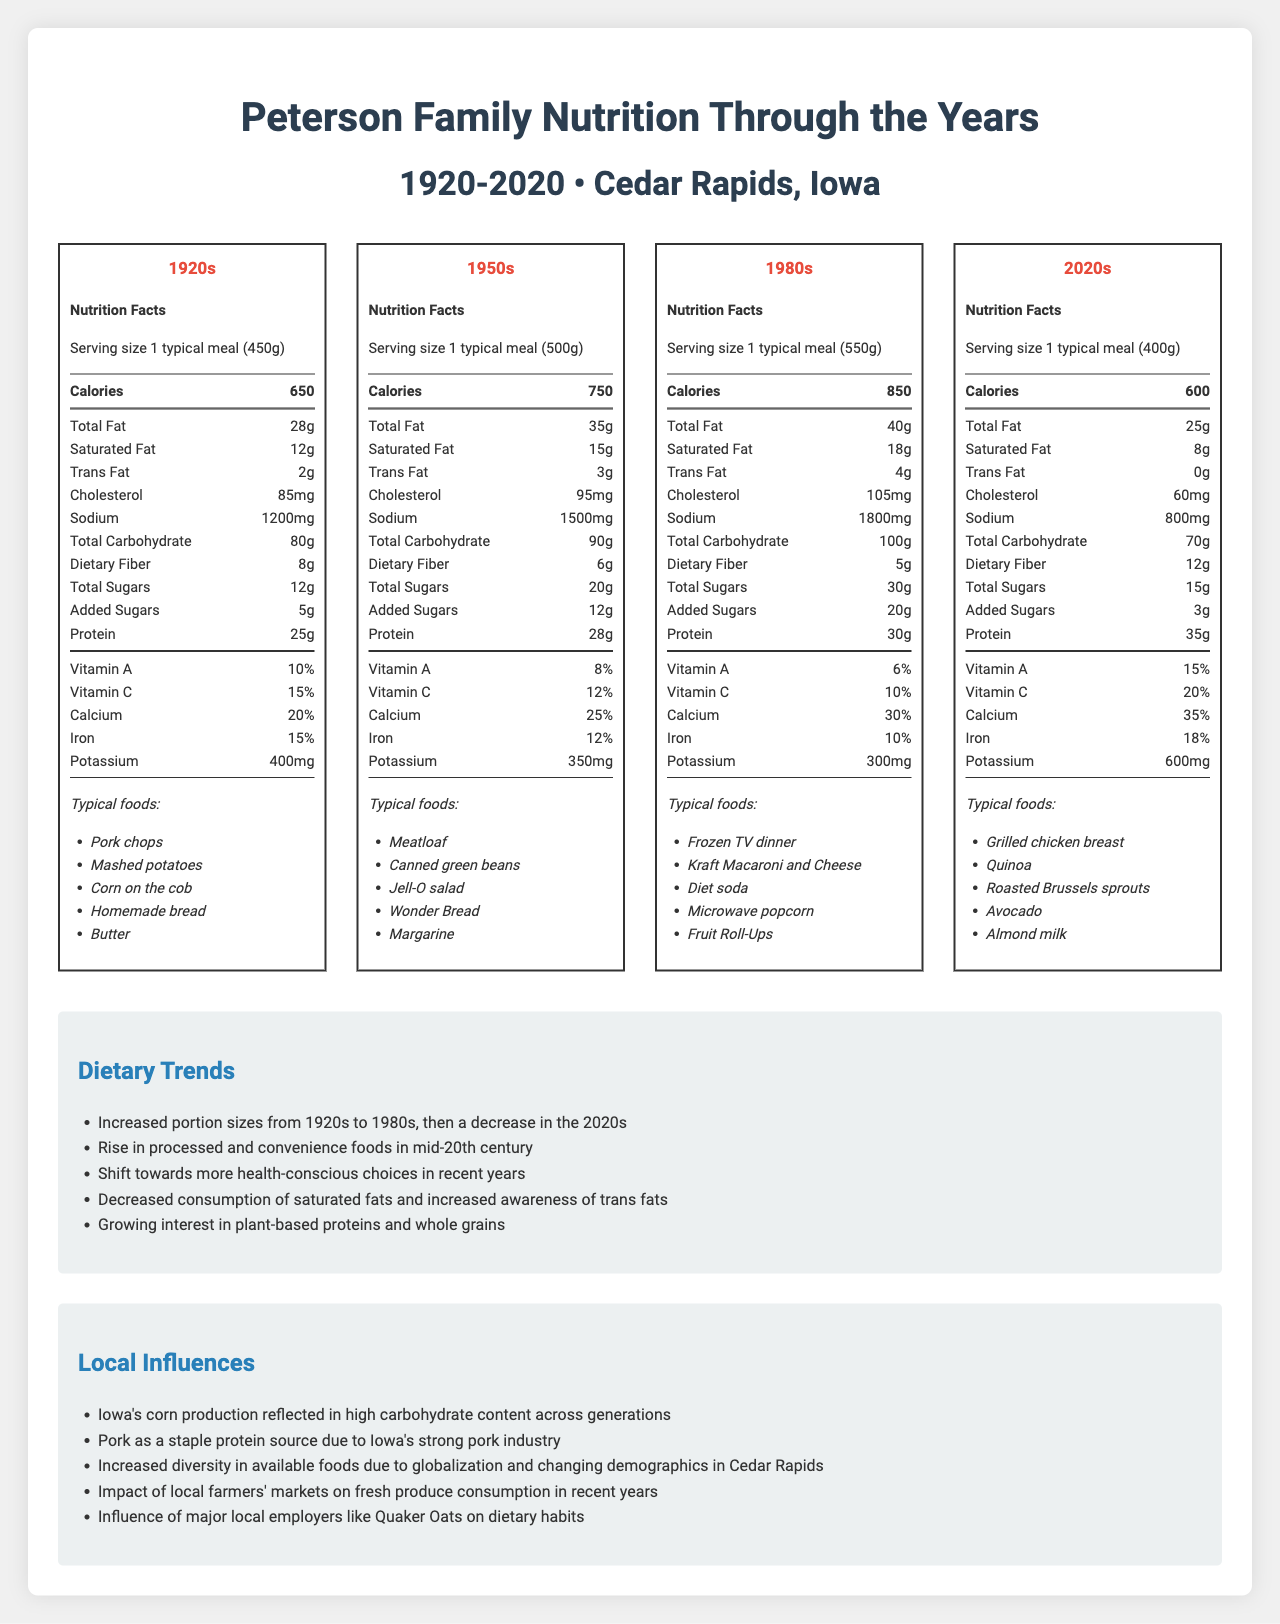how many calories are in a typical meal from the 1950s? According to the nutrition label from the 1950s era, a typical meal contains 750 calories.
Answer: 750 calories what is the serving size described for the 1980s? The nutrition label for the 1980s specifies that the serving size is "1 typical meal (550g)".
Answer: 1 typical meal (550g) how much protein is in a 2020s meal? The 2020s nutrition label lists 35 grams of protein per typical meal.
Answer: 35g what were the typical foods in the 1920s? The nutrition label for the 1920s lists these foods as typical for that era.
Answer: Pork chops, Mashed potatoes, Corn on the cob, Homemade bread, Butter which era had the highest sodium content in their meals? Meals from the 1980s had the highest sodium content at 1800mg.
Answer: 1980s which of the following foods is listed under the 1950s typical meal? A. Kraft Macaroni and Cheese B. Jell-O salad C. Avocado D. Quinoa The 1950s lists Jell-O salad as a typical food. The other options are from different eras.
Answer: B. Jell-O salad in which era did meals have the highest total carbohydrate content? A. 1920s B. 1950s C. 1980s D. 2020s Meals in the 1980s had the highest total carbohydrate content at 100g.
Answer: C. 1980s are there any trans fats listed in a 2020s meal? The nutrition label for the 2020s shows 0g of trans fats.
Answer: No summarize the main idea of the document. The document provides detailed nutrition facts per era, shows how dietary habits evolved, and identifies factors impacting those changes.
Answer: The document showcases the dietary changes in the Peterson family from Cedar Rapids, Iowa, over a timespan of 100 years (1920-2020). It highlights nutritional information, typical foods, dietary trends, and local influences across four different eras (1920s, 1950s, 1980s, and 2020s). The document observes increasing portion sizes from 1920s to 1980s, the rise of processed foods in the mid-20th century, and a shift towards health-conscious choices in recent years. It also notes the influences of local agriculture and global food diversification. what is the trend in added sugars content over the years? The 1920s had 5g of added sugars, the 1950s had 12g, the 1980s had 20g, and the 2020s had 3g.
Answer: The added sugars content increased from the 1920s to the 1980s and then decreased in the 2020s. how has the typical serving size changed from the 1920s to the 2020s? Initially, the serving size increased every era, peaking in the 1980s, before decreasing in the 2020s.
Answer: The serving size increased from the 1920s (450g) to the 1980s (550g) and then decreased in the 2020s (400g). what factor influenced the prominence of pork in Iowa diets? The document mentions that pork is a staple protein source due to Iowa's strong pork industry.
Answer: Iowa's strong pork industry how much vitamin A is in a typical 1920s meal? The nutrition label for the 1920s lists 10% Vitamin A content.
Answer: 10% which era had the lowest dietary fiber content? A. 1920s B. 1950s C. 1980s D. 2020s The 1980s nutrition label shows the lowest dietary fiber content with 5g.
Answer: C. 1980s did the document mention the exact years of family recipes? The document does not specify exact years for family recipes.
Answer: Cannot be determined 